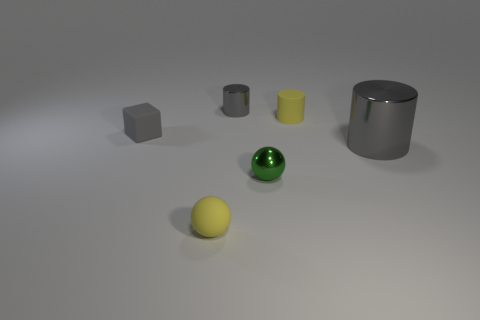Subtract all metal cylinders. How many cylinders are left? 1 Add 2 tiny yellow rubber spheres. How many objects exist? 8 Subtract all balls. How many objects are left? 4 Subtract 1 green balls. How many objects are left? 5 Subtract all large purple metallic cylinders. Subtract all tiny cylinders. How many objects are left? 4 Add 3 tiny matte spheres. How many tiny matte spheres are left? 4 Add 6 cyan things. How many cyan things exist? 6 